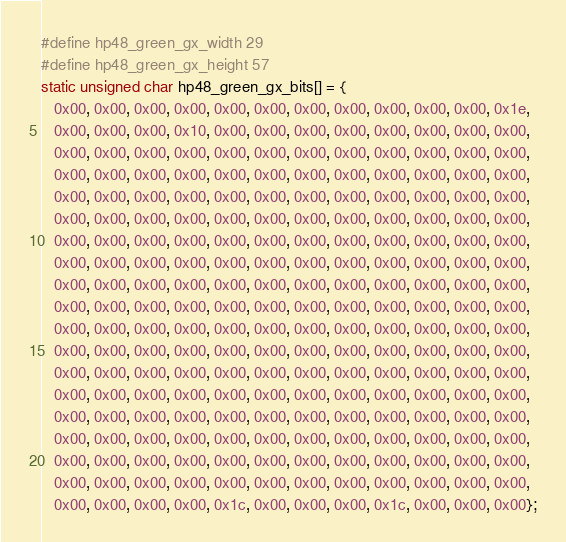<code> <loc_0><loc_0><loc_500><loc_500><_C_>#define hp48_green_gx_width 29
#define hp48_green_gx_height 57
static unsigned char hp48_green_gx_bits[] = {
   0x00, 0x00, 0x00, 0x00, 0x00, 0x00, 0x00, 0x00, 0x00, 0x00, 0x00, 0x1e,
   0x00, 0x00, 0x00, 0x10, 0x00, 0x00, 0x00, 0x00, 0x00, 0x00, 0x00, 0x00,
   0x00, 0x00, 0x00, 0x00, 0x00, 0x00, 0x00, 0x00, 0x00, 0x00, 0x00, 0x00,
   0x00, 0x00, 0x00, 0x00, 0x00, 0x00, 0x00, 0x00, 0x00, 0x00, 0x00, 0x00,
   0x00, 0x00, 0x00, 0x00, 0x00, 0x00, 0x00, 0x00, 0x00, 0x00, 0x00, 0x00,
   0x00, 0x00, 0x00, 0x00, 0x00, 0x00, 0x00, 0x00, 0x00, 0x00, 0x00, 0x00,
   0x00, 0x00, 0x00, 0x00, 0x00, 0x00, 0x00, 0x00, 0x00, 0x00, 0x00, 0x00,
   0x00, 0x00, 0x00, 0x00, 0x00, 0x00, 0x00, 0x00, 0x00, 0x00, 0x00, 0x00,
   0x00, 0x00, 0x00, 0x00, 0x00, 0x00, 0x00, 0x00, 0x00, 0x00, 0x00, 0x00,
   0x00, 0x00, 0x00, 0x00, 0x00, 0x00, 0x00, 0x00, 0x00, 0x00, 0x00, 0x00,
   0x00, 0x00, 0x00, 0x00, 0x00, 0x00, 0x00, 0x00, 0x00, 0x00, 0x00, 0x00,
   0x00, 0x00, 0x00, 0x00, 0x00, 0x00, 0x00, 0x00, 0x00, 0x00, 0x00, 0x00,
   0x00, 0x00, 0x00, 0x00, 0x00, 0x00, 0x00, 0x00, 0x00, 0x00, 0x00, 0x00,
   0x00, 0x00, 0x00, 0x00, 0x00, 0x00, 0x00, 0x00, 0x00, 0x00, 0x00, 0x00,
   0x00, 0x00, 0x00, 0x00, 0x00, 0x00, 0x00, 0x00, 0x00, 0x00, 0x00, 0x00,
   0x00, 0x00, 0x00, 0x00, 0x00, 0x00, 0x00, 0x00, 0x00, 0x00, 0x00, 0x00,
   0x00, 0x00, 0x00, 0x00, 0x00, 0x00, 0x00, 0x00, 0x00, 0x00, 0x00, 0x00,
   0x00, 0x00, 0x00, 0x00, 0x00, 0x00, 0x00, 0x00, 0x00, 0x00, 0x00, 0x00,
   0x00, 0x00, 0x00, 0x00, 0x1c, 0x00, 0x00, 0x00, 0x1c, 0x00, 0x00, 0x00};

</code> 